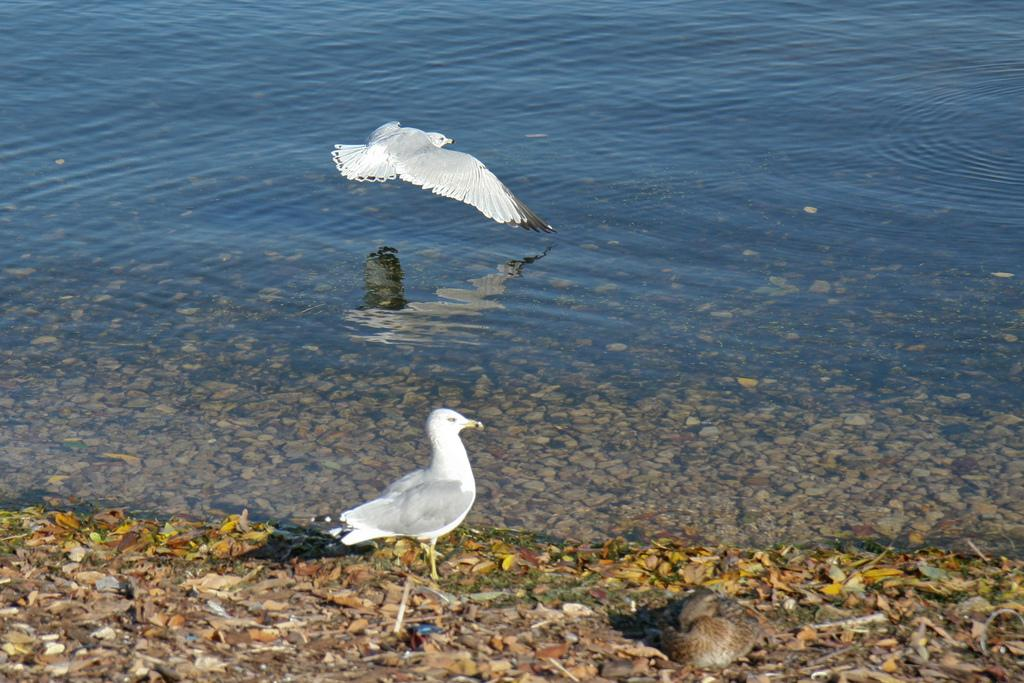What is the primary element visible in the image? There is water in the image. What type of animals can be seen in the water? There are two white color birds in the image. What else is present in the water besides the birds? There are small stones in the water. What type of beast is cooking the stew in the image? There is no beast or stew present in the image; it features water with two white color birds and small stones. 